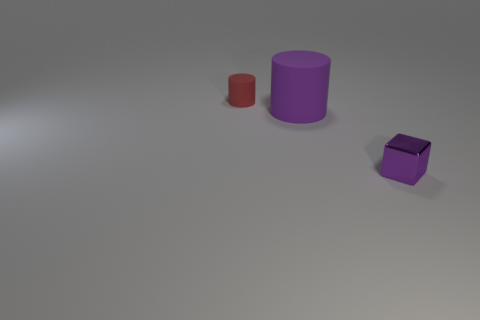Is the number of small metallic objects less than the number of tiny purple rubber cylinders?
Offer a very short reply. No. Are any matte objects visible?
Provide a succinct answer. Yes. What number of other things are there of the same size as the purple block?
Offer a terse response. 1. Do the tiny purple object and the cylinder in front of the tiny red thing have the same material?
Your answer should be very brief. No. Are there the same number of cylinders to the left of the small red cylinder and purple matte cylinders left of the purple matte object?
Ensure brevity in your answer.  Yes. What material is the red thing?
Provide a succinct answer. Rubber. The cylinder that is the same size as the purple metallic block is what color?
Offer a terse response. Red. Is there a tiny thing in front of the small object that is behind the purple cylinder?
Your answer should be very brief. Yes. How many spheres are tiny cyan things or red matte things?
Your response must be concise. 0. What size is the cylinder on the right side of the cylinder on the left side of the purple rubber object that is right of the red cylinder?
Offer a very short reply. Large. 